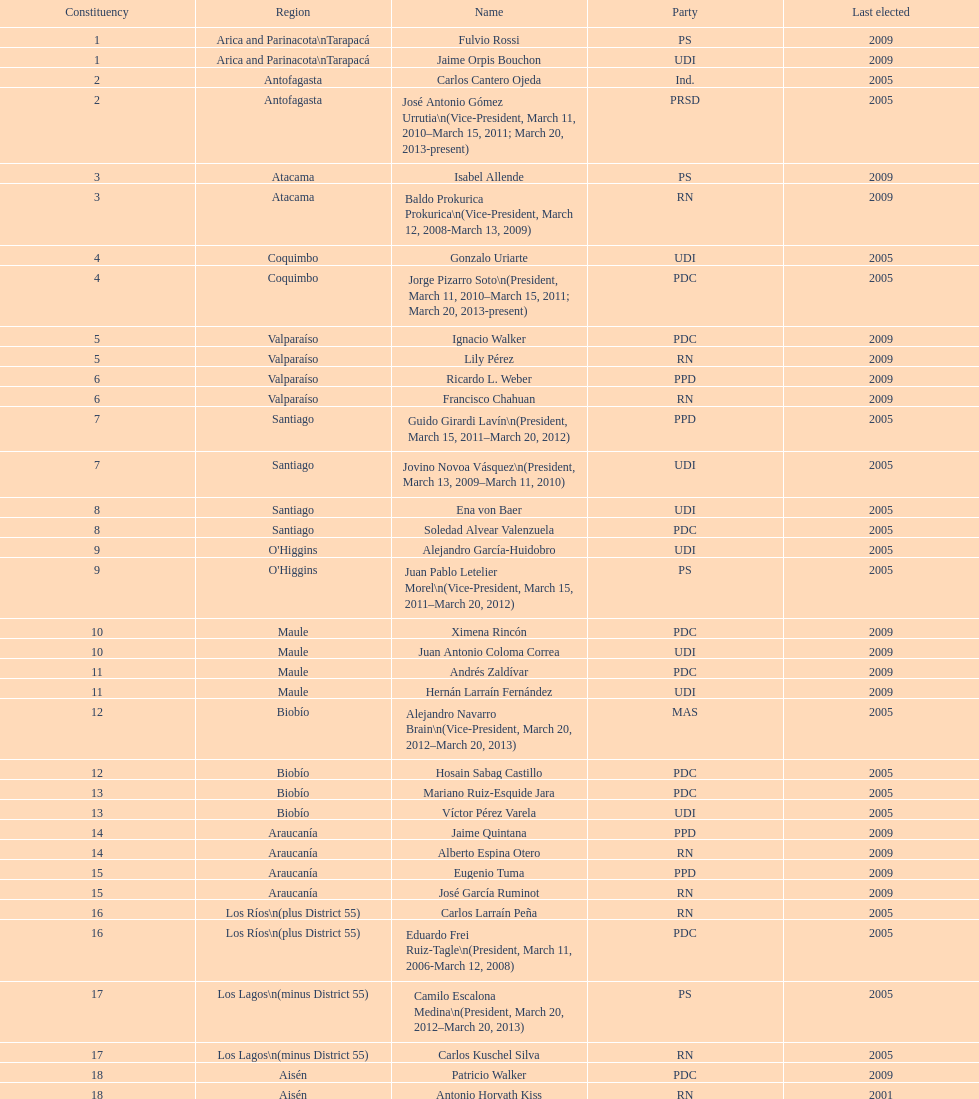I'm looking to parse the entire table for insights. Could you assist me with that? {'header': ['Constituency', 'Region', 'Name', 'Party', 'Last elected'], 'rows': [['1', 'Arica and Parinacota\\nTarapacá', 'Fulvio Rossi', 'PS', '2009'], ['1', 'Arica and Parinacota\\nTarapacá', 'Jaime Orpis Bouchon', 'UDI', '2009'], ['2', 'Antofagasta', 'Carlos Cantero Ojeda', 'Ind.', '2005'], ['2', 'Antofagasta', 'José Antonio Gómez Urrutia\\n(Vice-President, March 11, 2010–March 15, 2011; March 20, 2013-present)', 'PRSD', '2005'], ['3', 'Atacama', 'Isabel Allende', 'PS', '2009'], ['3', 'Atacama', 'Baldo Prokurica Prokurica\\n(Vice-President, March 12, 2008-March 13, 2009)', 'RN', '2009'], ['4', 'Coquimbo', 'Gonzalo Uriarte', 'UDI', '2005'], ['4', 'Coquimbo', 'Jorge Pizarro Soto\\n(President, March 11, 2010–March 15, 2011; March 20, 2013-present)', 'PDC', '2005'], ['5', 'Valparaíso', 'Ignacio Walker', 'PDC', '2009'], ['5', 'Valparaíso', 'Lily Pérez', 'RN', '2009'], ['6', 'Valparaíso', 'Ricardo L. Weber', 'PPD', '2009'], ['6', 'Valparaíso', 'Francisco Chahuan', 'RN', '2009'], ['7', 'Santiago', 'Guido Girardi Lavín\\n(President, March 15, 2011–March 20, 2012)', 'PPD', '2005'], ['7', 'Santiago', 'Jovino Novoa Vásquez\\n(President, March 13, 2009–March 11, 2010)', 'UDI', '2005'], ['8', 'Santiago', 'Ena von Baer', 'UDI', '2005'], ['8', 'Santiago', 'Soledad Alvear Valenzuela', 'PDC', '2005'], ['9', "O'Higgins", 'Alejandro García-Huidobro', 'UDI', '2005'], ['9', "O'Higgins", 'Juan Pablo Letelier Morel\\n(Vice-President, March 15, 2011–March 20, 2012)', 'PS', '2005'], ['10', 'Maule', 'Ximena Rincón', 'PDC', '2009'], ['10', 'Maule', 'Juan Antonio Coloma Correa', 'UDI', '2009'], ['11', 'Maule', 'Andrés Zaldívar', 'PDC', '2009'], ['11', 'Maule', 'Hernán Larraín Fernández', 'UDI', '2009'], ['12', 'Biobío', 'Alejandro Navarro Brain\\n(Vice-President, March 20, 2012–March 20, 2013)', 'MAS', '2005'], ['12', 'Biobío', 'Hosain Sabag Castillo', 'PDC', '2005'], ['13', 'Biobío', 'Mariano Ruiz-Esquide Jara', 'PDC', '2005'], ['13', 'Biobío', 'Víctor Pérez Varela', 'UDI', '2005'], ['14', 'Araucanía', 'Jaime Quintana', 'PPD', '2009'], ['14', 'Araucanía', 'Alberto Espina Otero', 'RN', '2009'], ['15', 'Araucanía', 'Eugenio Tuma', 'PPD', '2009'], ['15', 'Araucanía', 'José García Ruminot', 'RN', '2009'], ['16', 'Los Ríos\\n(plus District 55)', 'Carlos Larraín Peña', 'RN', '2005'], ['16', 'Los Ríos\\n(plus District 55)', 'Eduardo Frei Ruiz-Tagle\\n(President, March 11, 2006-March 12, 2008)', 'PDC', '2005'], ['17', 'Los Lagos\\n(minus District 55)', 'Camilo Escalona Medina\\n(President, March 20, 2012–March 20, 2013)', 'PS', '2005'], ['17', 'Los Lagos\\n(minus District 55)', 'Carlos Kuschel Silva', 'RN', '2005'], ['18', 'Aisén', 'Patricio Walker', 'PDC', '2009'], ['18', 'Aisén', 'Antonio Horvath Kiss', 'RN', '2001'], ['19', 'Magallanes', 'Carlos Bianchi Chelech\\n(Vice-President, March 13, 2009–March 11, 2010)', 'Ind.', '2005'], ['19', 'Magallanes', 'Pedro Muñoz Aburto', 'PS', '2005']]} Who was not last elected in either 2005 or 2009? Antonio Horvath Kiss. 